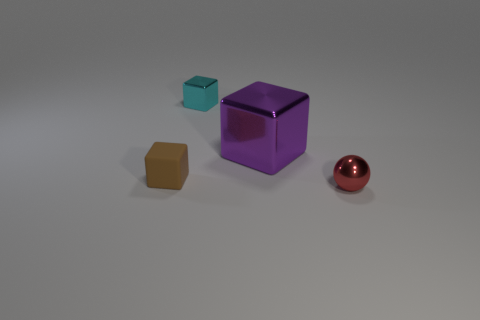There is a tiny metallic thing to the left of the metallic thing right of the big purple shiny cube; is there a tiny rubber block in front of it?
Give a very brief answer. Yes. There is a red object that is the same size as the cyan metallic thing; what shape is it?
Provide a succinct answer. Sphere. The other matte thing that is the same shape as the big purple object is what color?
Provide a succinct answer. Brown. What number of objects are either red matte things or metal cubes?
Your answer should be very brief. 2. There is a tiny metallic thing that is behind the large purple metallic object; does it have the same shape as the brown matte object in front of the big purple thing?
Your answer should be compact. Yes. There is a small thing that is behind the matte object; what is its shape?
Your answer should be compact. Cube. Is the number of small cyan metallic objects that are to the right of the brown matte cube the same as the number of brown rubber blocks that are behind the big purple metallic cube?
Provide a short and direct response. No. How many objects are big red matte things or small metallic things that are on the left side of the tiny red sphere?
Your answer should be very brief. 1. The object that is in front of the big purple thing and to the left of the sphere has what shape?
Offer a very short reply. Cube. What is the material of the block on the right side of the cube behind the purple cube?
Keep it short and to the point. Metal. 